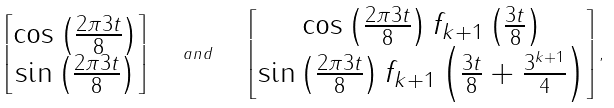<formula> <loc_0><loc_0><loc_500><loc_500>\left [ \begin{matrix} \cos \left ( \frac { 2 \pi 3 t } { 8 } \right ) \\ \sin \left ( \frac { 2 \pi 3 t } { 8 } \right ) \end{matrix} \right ] \quad a n d \quad \left [ \begin{matrix} \cos \left ( \frac { 2 \pi 3 t } { 8 } \right ) f _ { k + 1 } \left ( \frac { 3 t } { 8 } \right ) \\ \sin \left ( \frac { 2 \pi 3 t } { 8 } \right ) f _ { k + 1 } \left ( \frac { 3 t } { 8 } + \frac { 3 ^ { k + 1 } } { 4 } \right ) \end{matrix} \right ] ,</formula> 